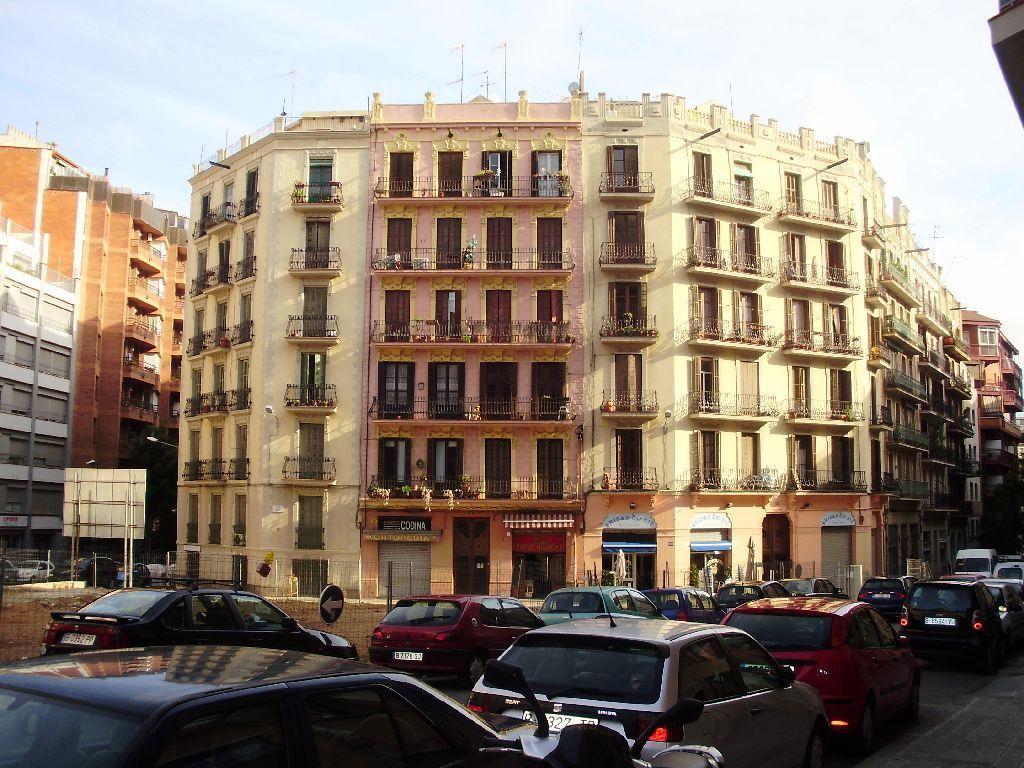Can you describe this image briefly? In this image there are cars on a road, in the background there is a buildings and a board and the sky. 